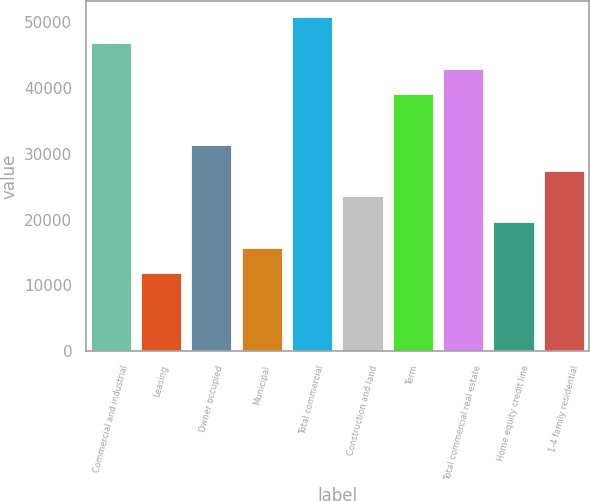Convert chart. <chart><loc_0><loc_0><loc_500><loc_500><bar_chart><fcel>Commercial and industrial<fcel>Leasing<fcel>Owner occupied<fcel>Municipal<fcel>Total commercial<fcel>Construction and land<fcel>Term<fcel>Total commercial real estate<fcel>Home equity credit line<fcel>1-4 family residential<nl><fcel>46810<fcel>11858.5<fcel>31276<fcel>15742<fcel>50693.5<fcel>23509<fcel>39043<fcel>42926.5<fcel>19625.5<fcel>27392.5<nl></chart> 